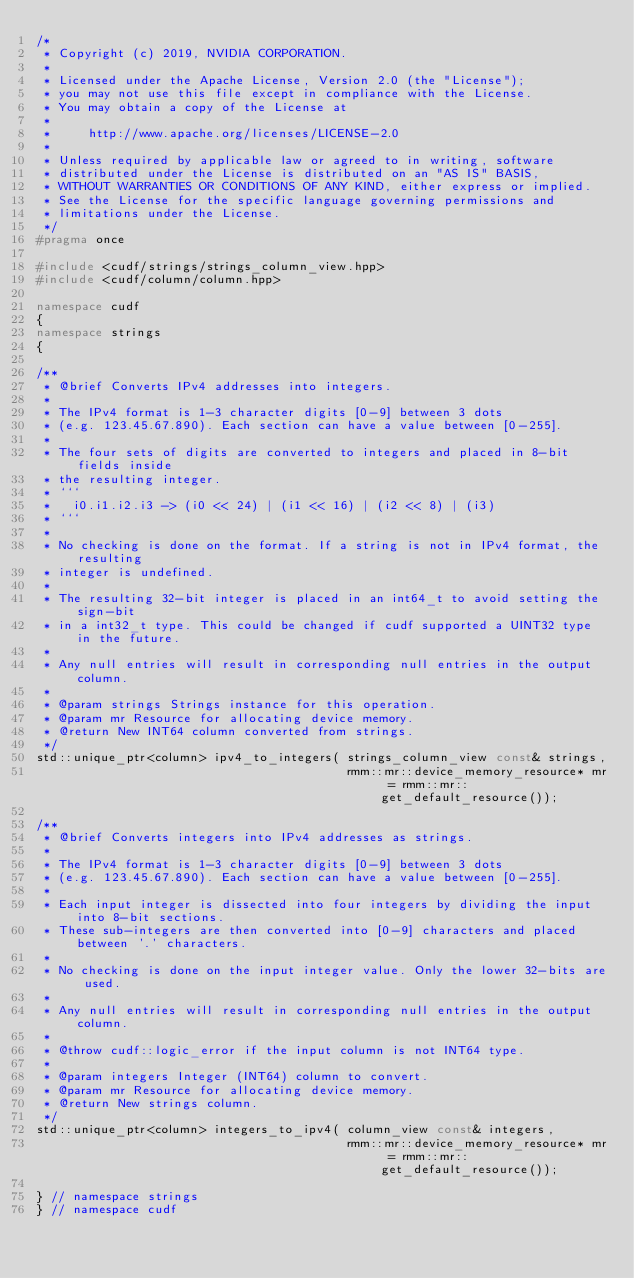Convert code to text. <code><loc_0><loc_0><loc_500><loc_500><_C++_>/*
 * Copyright (c) 2019, NVIDIA CORPORATION.
 *
 * Licensed under the Apache License, Version 2.0 (the "License");
 * you may not use this file except in compliance with the License.
 * You may obtain a copy of the License at
 *
 *     http://www.apache.org/licenses/LICENSE-2.0
 *
 * Unless required by applicable law or agreed to in writing, software
 * distributed under the License is distributed on an "AS IS" BASIS,
 * WITHOUT WARRANTIES OR CONDITIONS OF ANY KIND, either express or implied.
 * See the License for the specific language governing permissions and
 * limitations under the License.
 */
#pragma once

#include <cudf/strings/strings_column_view.hpp>
#include <cudf/column/column.hpp>

namespace cudf
{
namespace strings
{

/**
 * @brief Converts IPv4 addresses into integers.
 *
 * The IPv4 format is 1-3 character digits [0-9] between 3 dots
 * (e.g. 123.45.67.890). Each section can have a value between [0-255].
 *
 * The four sets of digits are converted to integers and placed in 8-bit fields inside
 * the resulting integer.
 * ```
 *   i0.i1.i2.i3 -> (i0 << 24) | (i1 << 16) | (i2 << 8) | (i3)
 * ```
 *
 * No checking is done on the format. If a string is not in IPv4 format, the resulting
 * integer is undefined.
 *
 * The resulting 32-bit integer is placed in an int64_t to avoid setting the sign-bit
 * in a int32_t type. This could be changed if cudf supported a UINT32 type in the future.
 *
 * Any null entries will result in corresponding null entries in the output column.
 *
 * @param strings Strings instance for this operation.
 * @param mr Resource for allocating device memory.
 * @return New INT64 column converted from strings.
 */
std::unique_ptr<column> ipv4_to_integers( strings_column_view const& strings,
                                          rmm::mr::device_memory_resource* mr = rmm::mr::get_default_resource());

/**
 * @brief Converts integers into IPv4 addresses as strings.
 *
 * The IPv4 format is 1-3 character digits [0-9] between 3 dots
 * (e.g. 123.45.67.890). Each section can have a value between [0-255].
 *
 * Each input integer is dissected into four integers by dividing the input into 8-bit sections.
 * These sub-integers are then converted into [0-9] characters and placed between '.' characters.
 *
 * No checking is done on the input integer value. Only the lower 32-bits are used.
 *
 * Any null entries will result in corresponding null entries in the output column.
 *
 * @throw cudf::logic_error if the input column is not INT64 type.
 *
 * @param integers Integer (INT64) column to convert.
 * @param mr Resource for allocating device memory.
 * @return New strings column.
 */
std::unique_ptr<column> integers_to_ipv4( column_view const& integers,
                                          rmm::mr::device_memory_resource* mr = rmm::mr::get_default_resource());

} // namespace strings
} // namespace cudf
</code> 